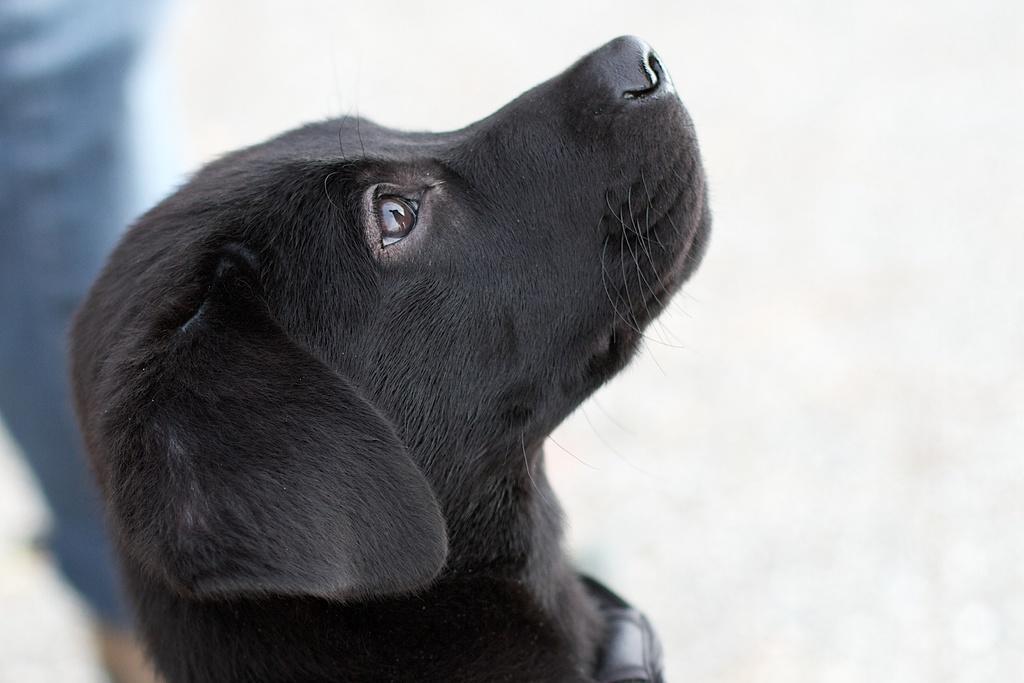Could you give a brief overview of what you see in this image? In this image, we can see a black dog. Background there is a blur view. Here we can see a blue color. 